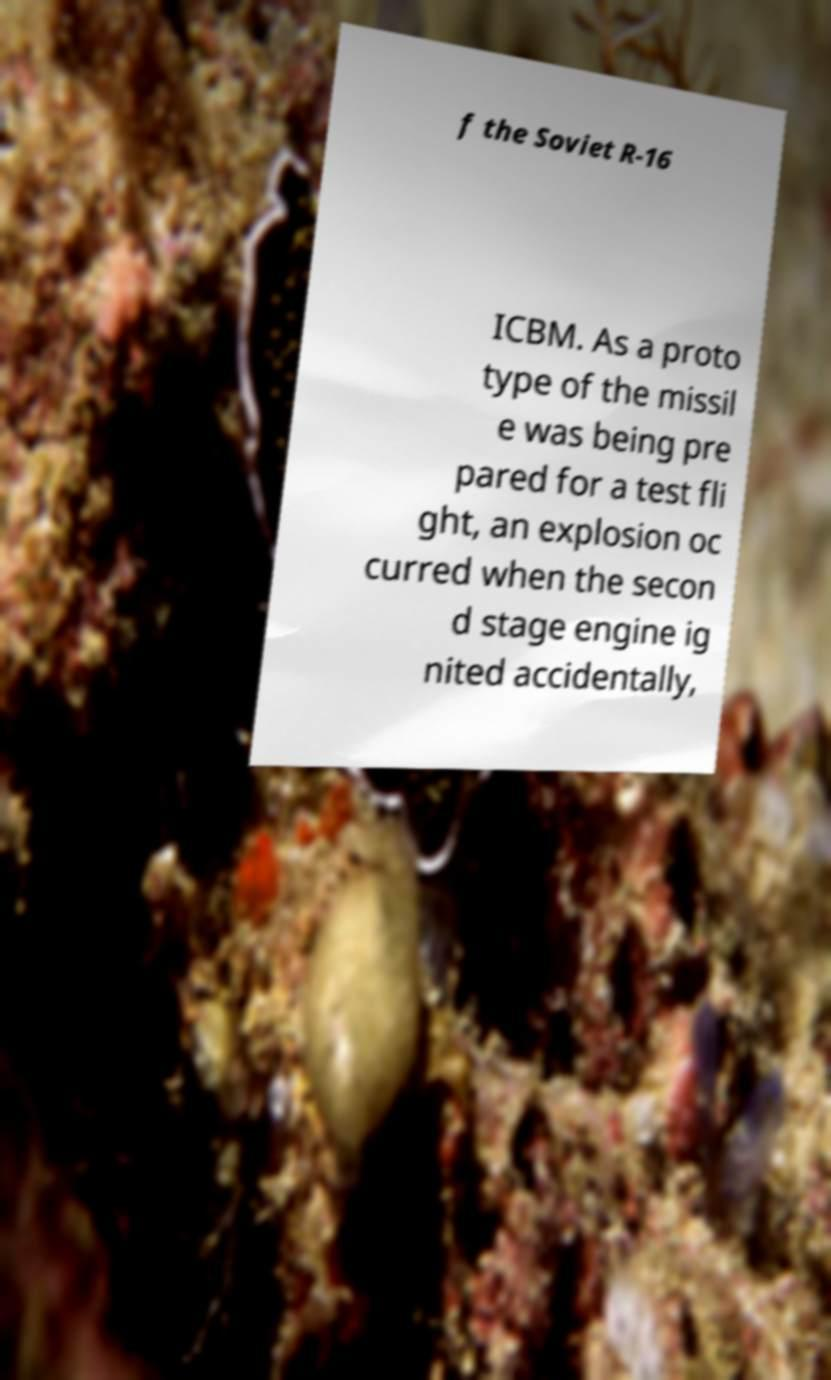There's text embedded in this image that I need extracted. Can you transcribe it verbatim? f the Soviet R-16 ICBM. As a proto type of the missil e was being pre pared for a test fli ght, an explosion oc curred when the secon d stage engine ig nited accidentally, 